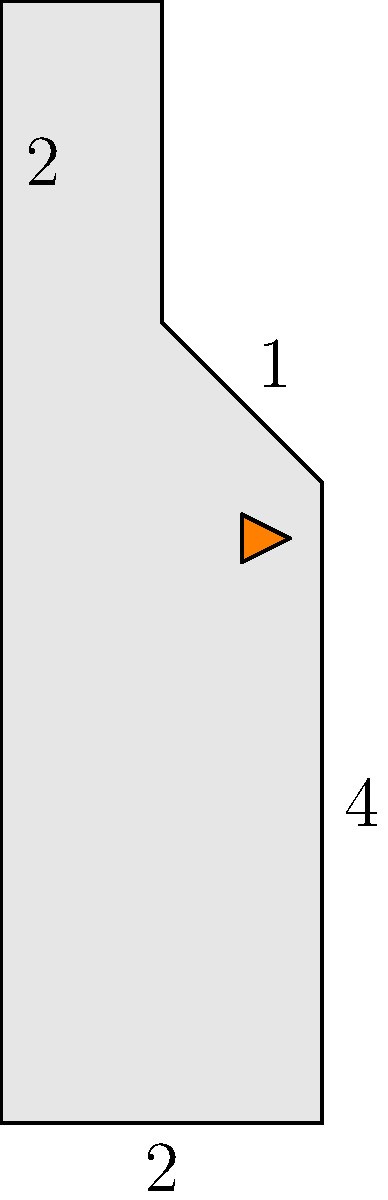Howdy, country music lover! Imagine Page Fortuna's iconic boot-shaped guitar case. The case has a rectangular base of 2 units by 4 units, with a 1 unit by 2 units extension at the top for the boot shaft. What's the total surface area of this boot-shaped case, including the top and bottom? (Assume the case has negligible thickness.) Let's break this down step-by-step, just like a good country song:

1) First, let's identify the surfaces:
   - Bottom (rectangle): 2 × 4
   - Top (boot shape): 2 × 4 + 1 × 2
   - Front and back (identical): 2 × 4 + 1 × 2
   - Left side: 4 × 1 + 2 × 1
   - Right side: 4 × 1

2) Now, let's calculate each surface area:
   - Bottom: $A_1 = 2 \times 4 = 8$ square units
   - Top: $A_2 = (2 \times 4) + (1 \times 2) = 8 + 2 = 10$ square units
   - Front: $A_3 = (2 \times 4) + (1 \times 2) = 8 + 2 = 10$ square units
   - Back: $A_4 = 10$ square units (same as front)
   - Left side: $A_5 = (4 \times 1) + (2 \times 1) = 4 + 2 = 6$ square units
   - Right side: $A_6 = 4 \times 1 = 4$ square units

3) Finally, let's add all these areas together:
   
   $A_{total} = A_1 + A_2 + A_3 + A_4 + A_5 + A_6$
   $A_{total} = 8 + 10 + 10 + 10 + 6 + 4 = 48$ square units

Therefore, the total surface area of Page Fortuna's boot-shaped guitar case is 48 square units.
Answer: 48 square units 